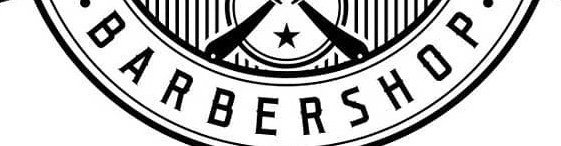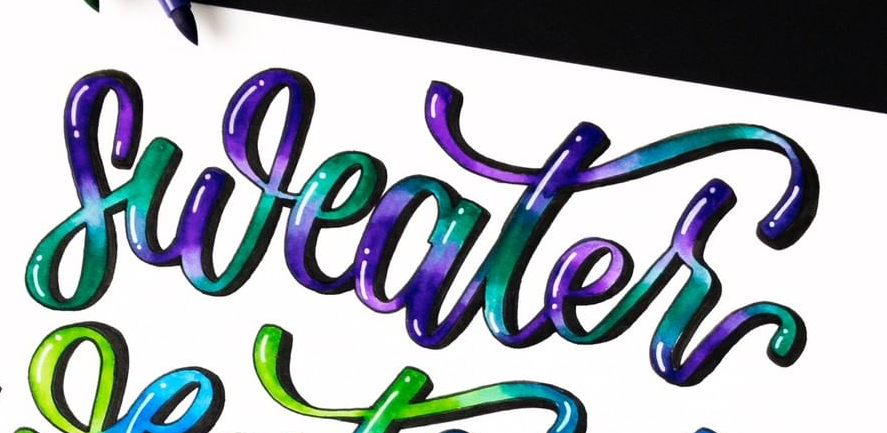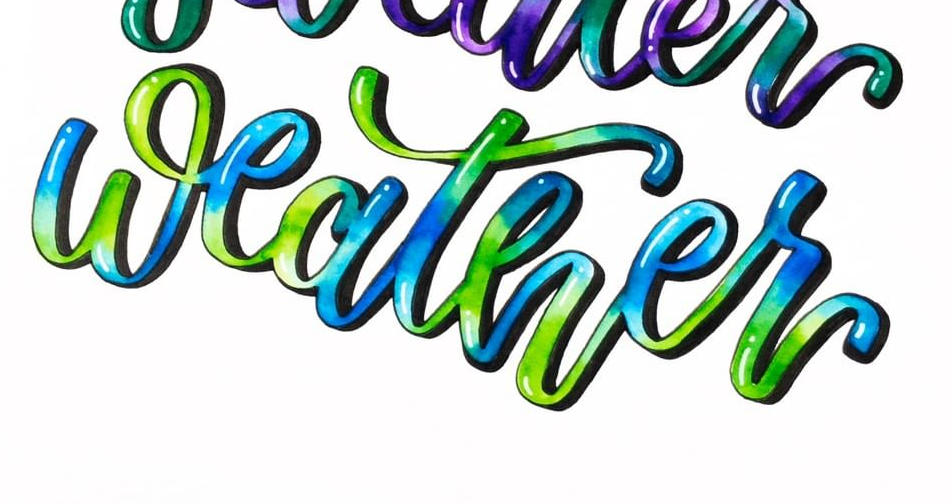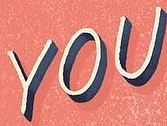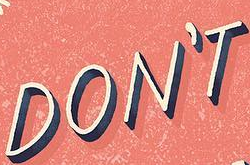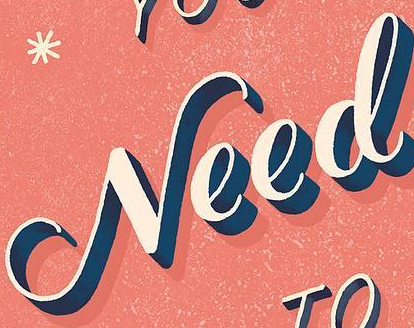What words are shown in these images in order, separated by a semicolon? BARBERSHOP; sweater; weather; YOU; DON'T; Need 